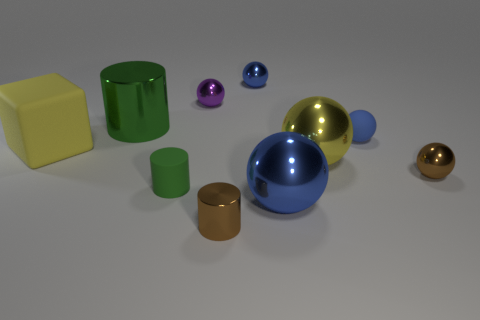Subtract all blue balls. How many were subtracted if there are2blue balls left? 1 Subtract all small purple shiny balls. How many balls are left? 5 Subtract all yellow balls. How many balls are left? 5 Subtract 2 cylinders. How many cylinders are left? 1 Add 3 big cubes. How many big cubes are left? 4 Add 5 small purple matte spheres. How many small purple matte spheres exist? 5 Subtract 0 gray cylinders. How many objects are left? 10 Subtract all spheres. How many objects are left? 4 Subtract all gray cubes. Subtract all gray balls. How many cubes are left? 1 Subtract all brown blocks. How many green cylinders are left? 2 